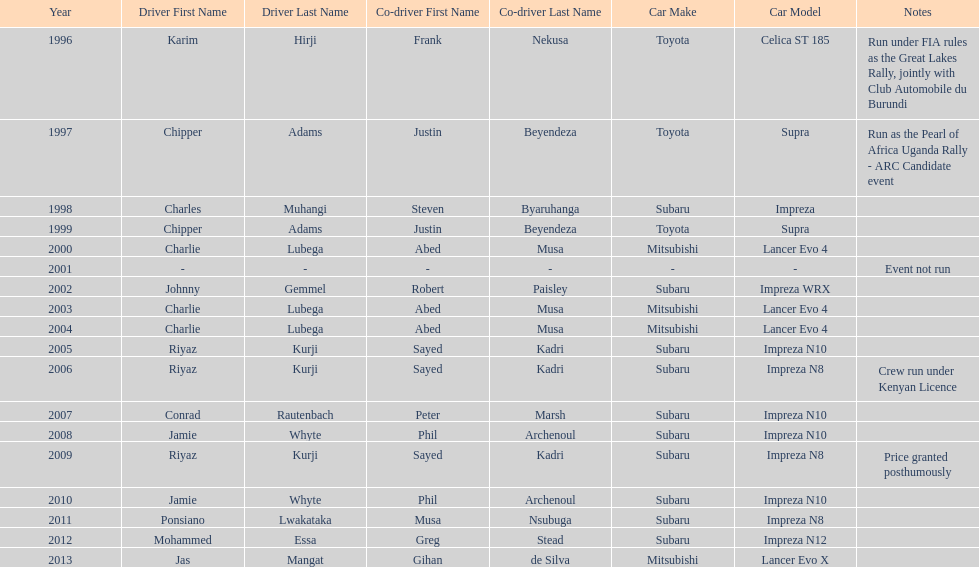Who is the only driver to have consecutive wins? Charlie Lubega. 